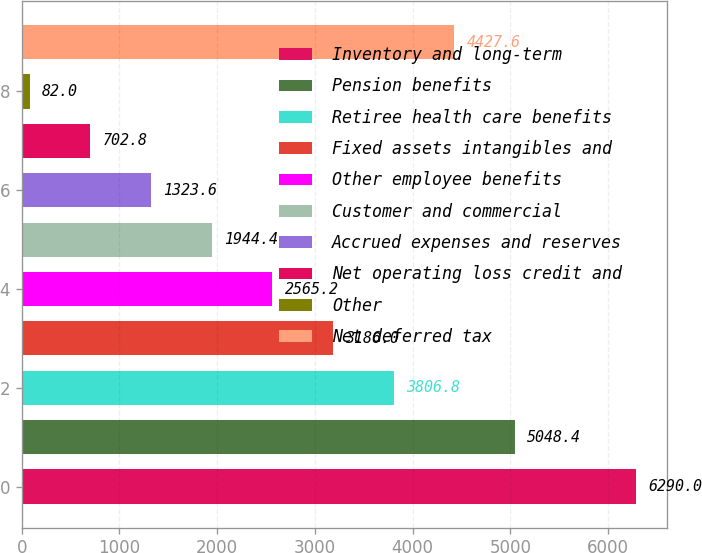Convert chart to OTSL. <chart><loc_0><loc_0><loc_500><loc_500><bar_chart><fcel>Inventory and long-term<fcel>Pension benefits<fcel>Retiree health care benefits<fcel>Fixed assets intangibles and<fcel>Other employee benefits<fcel>Customer and commercial<fcel>Accrued expenses and reserves<fcel>Net operating loss credit and<fcel>Other<fcel>Net deferred tax<nl><fcel>6290<fcel>5048.4<fcel>3806.8<fcel>3186<fcel>2565.2<fcel>1944.4<fcel>1323.6<fcel>702.8<fcel>82<fcel>4427.6<nl></chart> 